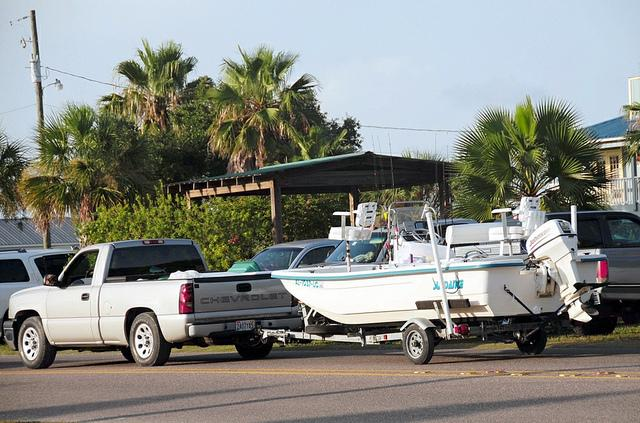What type of area is this? tropical 